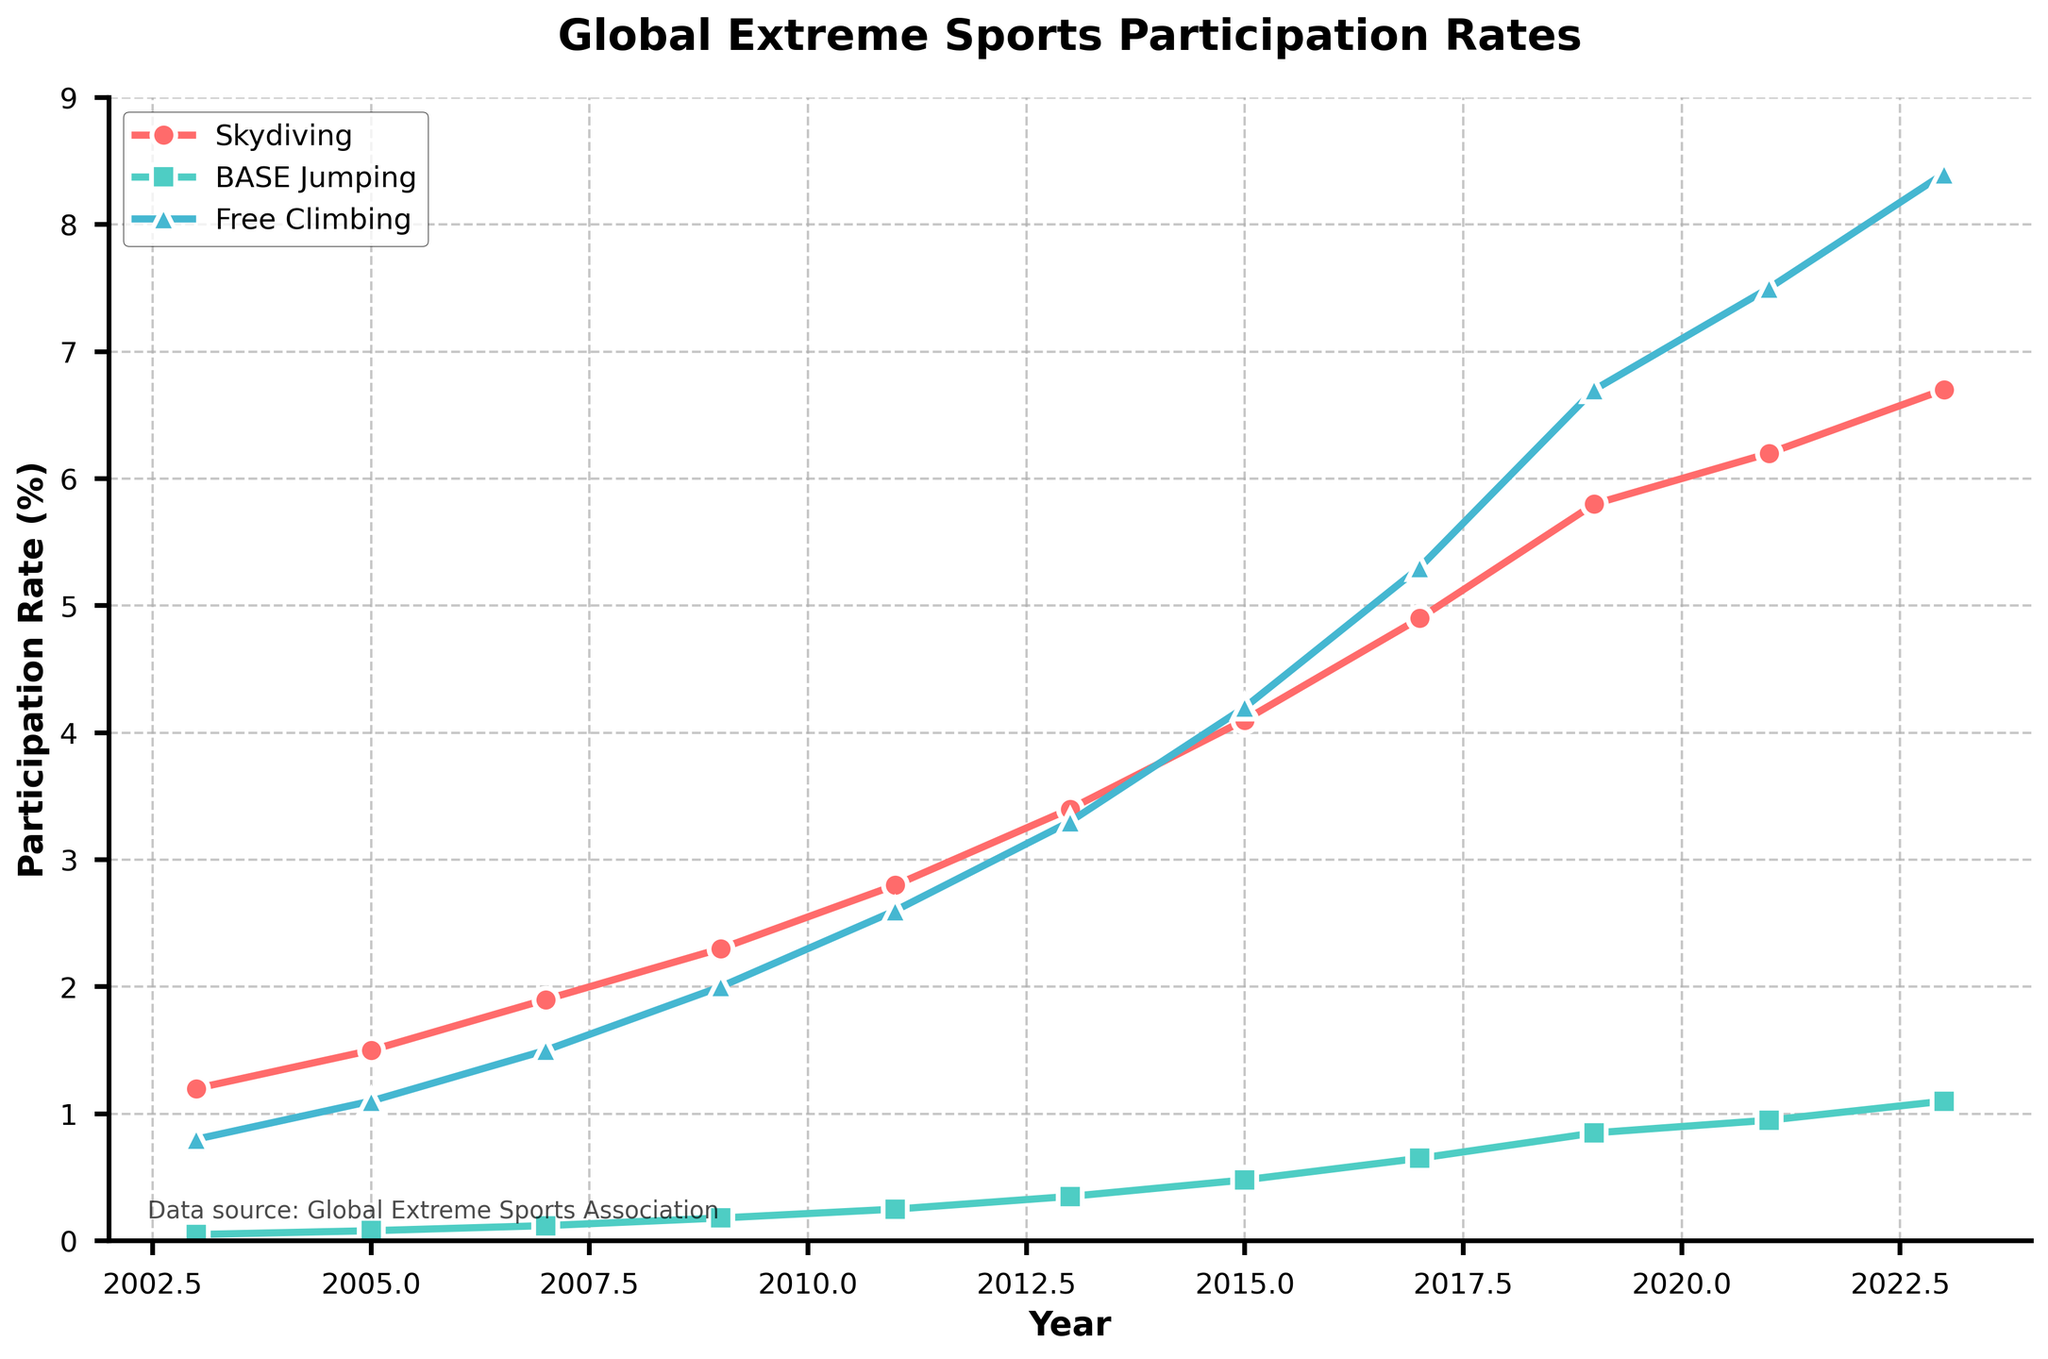What is the participation rate of Free Climbing in 2023? Look at the year 2023 and identify the value for Free Climbing
Answer: 8.4 Which sport had the highest participation rate in 2015? For the year 2015, compare the participation rates of Skydiving, BASE Jumping, and Free Climbing. Skydiving has the highest value at 4.1%
Answer: Skydiving Is the trend of participation rate for BASE Jumping consistently increasing over the years shown in the chart? Examine the values for BASE Jumping from 2003 to 2023. The values are consistently increasing from 0.05 in 2003 to 1.10 in 2023
Answer: Yes Which of the three sports had the lowest participation rate in 2009? In 2009, compare the participation rates of Skydiving, BASE Jumping, and Free Climbing. BASE Jumping has the lowest rate at 0.18%
Answer: BASE Jumping By how much did the participation rate of Skydiving increase from 2003 to 2023? Subtract the value of Skydiving participation in 2003 (1.2%) from its value in 2023 (6.7%): 6.7 - 1.2 = 5.5%
Answer: 5.5% During which year did Free Climbing surpass a participation rate of 5%? Observe the values for Free Climbing and identify the year where it first exceeds 5%. This happens in 2017 with a participation rate of 5.3%
Answer: 2017 Which sport had the slowest growth rate if we look at its participation increase from 2003 to 2023? Calculate the increase for each sport and compare: Skydiving (6.7 - 1.2 = 5.5%), BASE Jumping (1.10 - 0.05 = 1.05%), Free Climbing (8.4 - 0.8 = 7.6%). The slowest growth is BASE Jumping
Answer: BASE Jumping What is the average participation rate for Skydiving over the given decades? Add the values for Skydiving (1.2 + 1.5 + 1.9 + 2.3 + 2.8 + 3.4 + 4.1 + 4.9 + 5.8 + 6.2 + 6.7) and divide by the number of years (11): (41.8 / 11 ≈ 3.80)
Answer: 3.80 In which period (between two given years) was the increase in participation rate for Free Climbing the highest? Calculate the increase between consecutive years and identify the maximum jump: between 2015 and 2017 (5.3 - 4.2 = 1.1%)
Answer: 2015-2017 Comparing the visual attributes of the lines, which sport is represented by a line with triangle markers? Identify the line that has triangle markers. The line representing Free Climbing has triangle markers
Answer: Free Climbing 